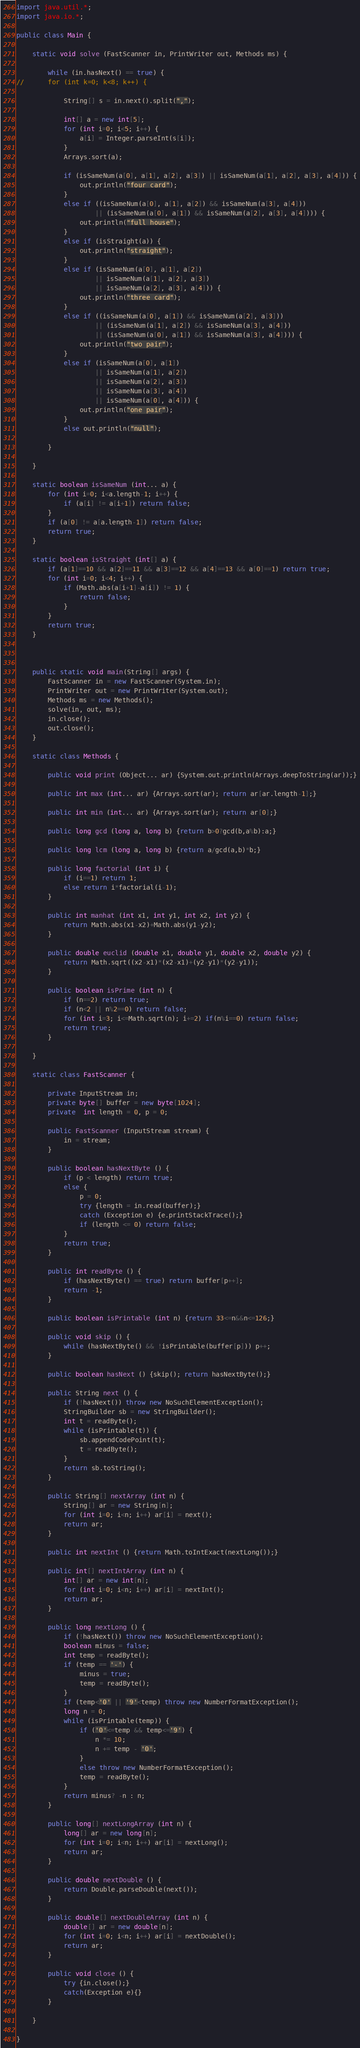<code> <loc_0><loc_0><loc_500><loc_500><_Java_>import java.util.*;
import java.io.*;

public class Main {

	static void solve (FastScanner in, PrintWriter out, Methods ms) {

		while (in.hasNext() == true) {
//		for (int k=0; k<8; k++) {
			
			String[] s = in.next().split(",");
			
			int[] a = new int[5];
			for (int i=0; i<5; i++) {
				a[i] = Integer.parseInt(s[i]);
			}
			Arrays.sort(a);

			if (isSameNum(a[0], a[1], a[2], a[3]) || isSameNum(a[1], a[2], a[3], a[4])) {
				out.println("four card");
			}
			else if ((isSameNum(a[0], a[1], a[2]) && isSameNum(a[3], a[4]))
					|| (isSameNum(a[0], a[1]) && isSameNum(a[2], a[3], a[4]))) {
				out.println("full house");
			}
			else if (isStraight(a)) {
				out.println("straight");
			}
			else if (isSameNum(a[0], a[1], a[2])
					|| isSameNum(a[1], a[2], a[3])
					|| isSameNum(a[2], a[3], a[4])) {
				out.println("three card");
			}
			else if ((isSameNum(a[0], a[1]) && isSameNum(a[2], a[3]))
					|| (isSameNum(a[1], a[2]) && isSameNum(a[3], a[4]))
					|| (isSameNum(a[0], a[1]) && isSameNum(a[3], a[4]))) {
				out.println("two pair");
			}
			else if (isSameNum(a[0], a[1])
					|| isSameNum(a[1], a[2])
					|| isSameNum(a[2], a[3])
					|| isSameNum(a[3], a[4])
					|| isSameNum(a[0], a[4])) {
				out.println("one pair");
			}
			else out.println("null");

		}

	}

	static boolean isSameNum (int... a) {
		for (int i=0; i<a.length-1; i++) {
			if (a[i] != a[i+1]) return false;
		}
		if (a[0] != a[a.length-1]) return false;
		return true;
	}

	static boolean isStraight (int[] a) {
		if (a[1]==10 && a[2]==11 && a[3]==12 && a[4]==13 && a[0]==1) return true;
		for (int i=0; i<4; i++) {
			if (Math.abs(a[i+1]-a[i]) != 1) {
				return false;
			}
		}
		return true;
	}



	public static void main(String[] args) {
		FastScanner in = new FastScanner(System.in);
		PrintWriter out = new PrintWriter(System.out);
		Methods ms = new Methods();
		solve(in, out, ms);
		in.close();
		out.close();
	}

	static class Methods {

		public void print (Object... ar) {System.out.println(Arrays.deepToString(ar));}

		public int max (int... ar) {Arrays.sort(ar); return ar[ar.length-1];}

		public int min (int... ar) {Arrays.sort(ar); return ar[0];}

		public long gcd (long a, long b) {return b>0?gcd(b,a%b):a;}

		public long lcm (long a, long b) {return a/gcd(a,b)*b;}

		public long factorial (int i) {
			if (i==1) return 1;
			else return i*factorial(i-1);
		}

		public int manhat (int x1, int y1, int x2, int y2) {
			return Math.abs(x1-x2)+Math.abs(y1-y2);
		}

		public double euclid (double x1, double y1, double x2, double y2) {
			return Math.sqrt((x2-x1)*(x2-x1)+(y2-y1)*(y2-y1));
		}

		public boolean isPrime (int n) {
			if (n==2) return true;
			if (n<2 || n%2==0) return false;
			for (int i=3; i<=Math.sqrt(n); i+=2) if(n%i==0) return false;
			return true;
		}

	}

	static class FastScanner {

		private InputStream in;
		private byte[] buffer = new byte[1024];
		private  int length = 0, p = 0;

		public FastScanner (InputStream stream) {
			in = stream;
		}

		public boolean hasNextByte () {
			if (p < length) return true;
			else {
				p = 0;
				try {length = in.read(buffer);}
				catch (Exception e) {e.printStackTrace();}
				if (length <= 0) return false;
			}
			return true;
		}

		public int readByte () {
			if (hasNextByte() == true) return buffer[p++];
			return -1;
		}

		public boolean isPrintable (int n) {return 33<=n&&n<=126;}

		public void skip () {
			while (hasNextByte() && !isPrintable(buffer[p])) p++;
		}

		public boolean hasNext () {skip(); return hasNextByte();}

		public String next () {
			if (!hasNext()) throw new NoSuchElementException();
			StringBuilder sb = new StringBuilder();
			int t = readByte();
			while (isPrintable(t)) {
				sb.appendCodePoint(t);
				t = readByte();
			}
			return sb.toString();
		}

		public String[] nextArray (int n) {
			String[] ar = new String[n];
			for (int i=0; i<n; i++) ar[i] = next();
			return ar;
		}

		public int nextInt () {return Math.toIntExact(nextLong());}

		public int[] nextIntArray (int n) {
			int[] ar = new int[n];
			for (int i=0; i<n; i++) ar[i] = nextInt();
			return ar;
		}

		public long nextLong () {
			if (!hasNext()) throw new NoSuchElementException();
			boolean minus = false;
			int temp = readByte();
			if (temp == '-') {
				minus = true;
				temp = readByte();
			}
			if (temp<'0' || '9'<temp) throw new NumberFormatException();
			long n = 0;
			while (isPrintable(temp)) {
				if ('0'<=temp && temp<='9') {
					n *= 10;
					n += temp - '0';
				}
				else throw new NumberFormatException();
				temp = readByte();
			}
			return minus? -n : n;
		}

		public long[] nextLongArray (int n) {
			long[] ar = new long[n];
			for (int i=0; i<n; i++) ar[i] = nextLong();
			return ar;
		}

		public double nextDouble () {
			return Double.parseDouble(next());
		}

		public double[] nextDoubleArray (int n) {
			double[] ar = new double[n];
			for (int i=0; i<n; i++) ar[i] = nextDouble();
			return ar;
		}

		public void close () {
			try {in.close();}
			catch(Exception e){}
		}

	}

}
</code> 